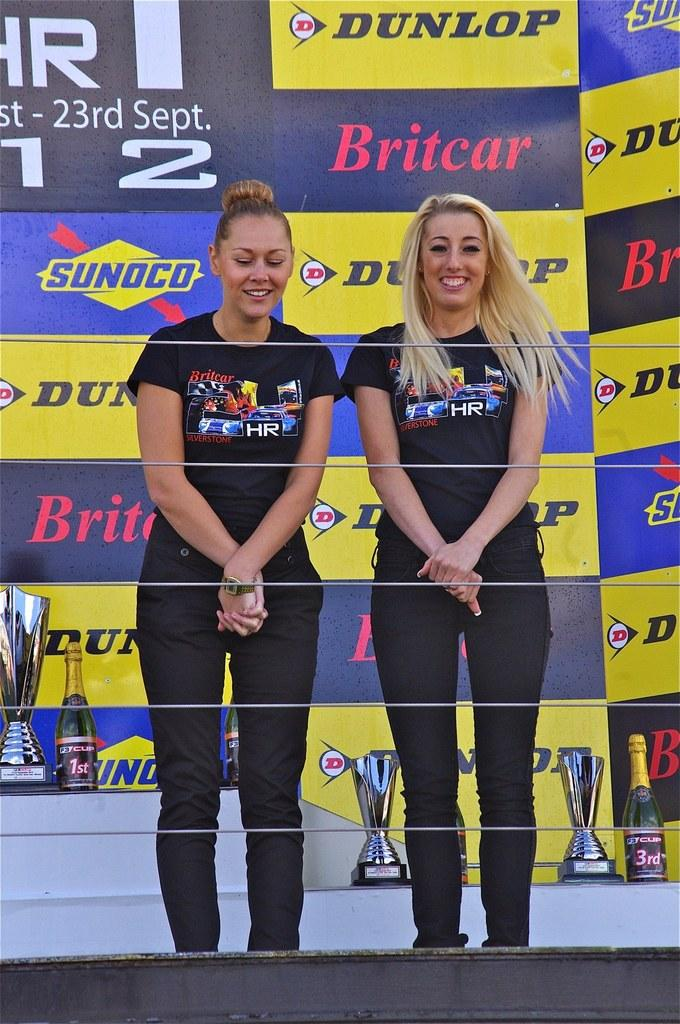Provide a one-sentence caption for the provided image. Two females pose in front of a banner representing companies such as Dunlop, Sunoco and Britcar. 